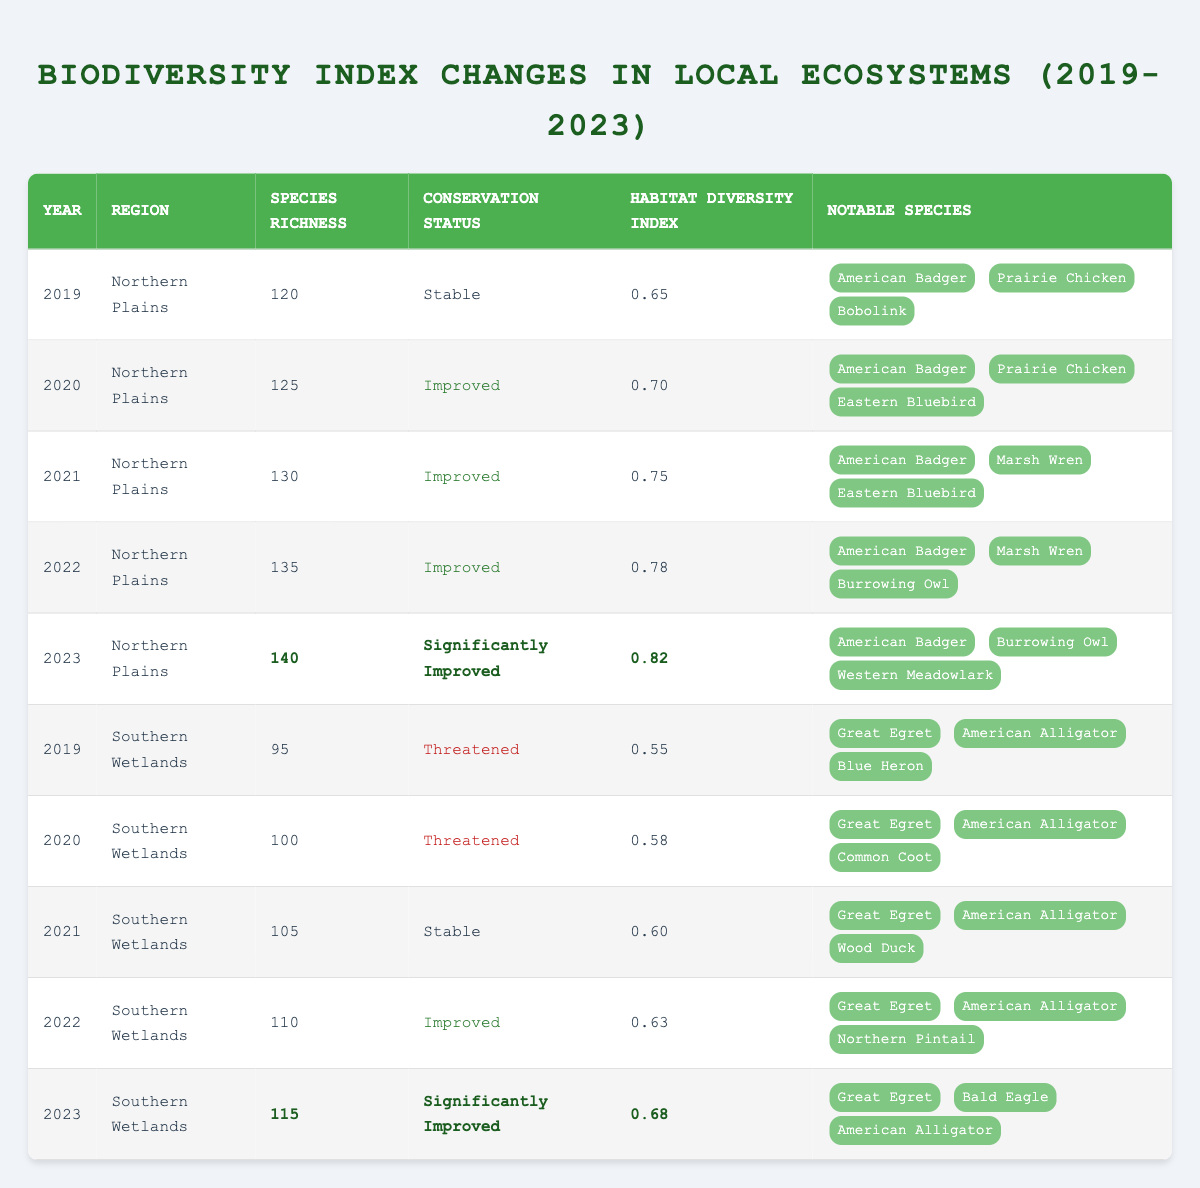What was the species richness in the Northern Plains in 2023? In the row for the year 2023 under the Northern Plains, the species richness is listed as 140.
Answer: 140 What is the habitat diversity index for the Southern Wetlands in 2021? Looking at the row for the year 2021 under the Southern Wetlands, the habitat diversity index is recorded as 0.60.
Answer: 0.60 How many notable species were listed for the Northern Plains in 2022? In the Northern Plains for the year 2022, the notable species listed are three: American Badger, Marsh Wren, and Burrowing Owl. Thus, the total is 3.
Answer: 3 Which region had a conservation status of "Threatened" in 2020? Checking the year 2020, the Southern Wetlands had a conservation status listed as "Threatened."
Answer: Southern Wetlands What was the increase in species richness from 2019 to 2023 for the Northern Plains? In 2019, the species richness was 120, and in 2023 it was 140. The increase is calculated as 140 - 120 = 20.
Answer: 20 Was there any year in the Southern Wetlands from 2019 to 2023 where species richness declined? By examining the data, there is no year listed in the Southern Wetlands where species richness decreased; it consistently either improved or remained stable. Therefore, the statement is false.
Answer: No What is the average habitat diversity index for the Northern Plains over the five years? The habitat diversity index values for the Northern Plains are 0.65, 0.70, 0.75, 0.78, and 0.82. Adding these gives 0.65 + 0.70 + 0.75 + 0.78 + 0.82 = 3.70, and dividing by 5 gives an average of 3.70 / 5 = 0.74.
Answer: 0.74 Which year showed the most significant improvement in conservation status for the Northern Plains? Looking at the conservation status over the years, in 2023 the status is "Significantly Improved", which is the most positive indication compared to previous years where the maximum status was "Improved".
Answer: 2023 How many total notable species were recorded in the Southern Wetlands across all years? Notable species in Southern Wetlands include: (2019: 3 species, 2020: 3 species, 2021: 3 species, 2022: 3 species, 2023: 3 species). Therefore, totaling 3 + 3 + 3 + 3 + 3 = 15 notable species, noting that the species are repeated across years.
Answer: 15 In which year did the Northern Plains first achieve a habitat diversity index greater than 0.76? By reviewing the values for habitat diversity index in Northern Plains, it first exceeds 0.76 in the year 2022, where it was recorded as 0.78.
Answer: 2022 